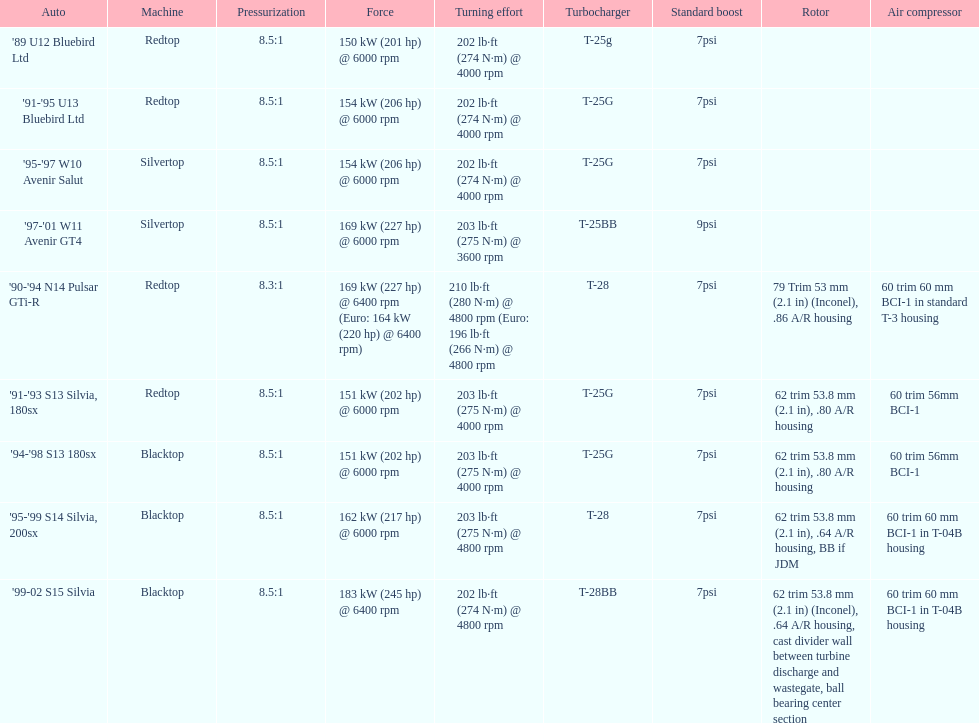Which engine(s) has the least amount of power? Redtop. 